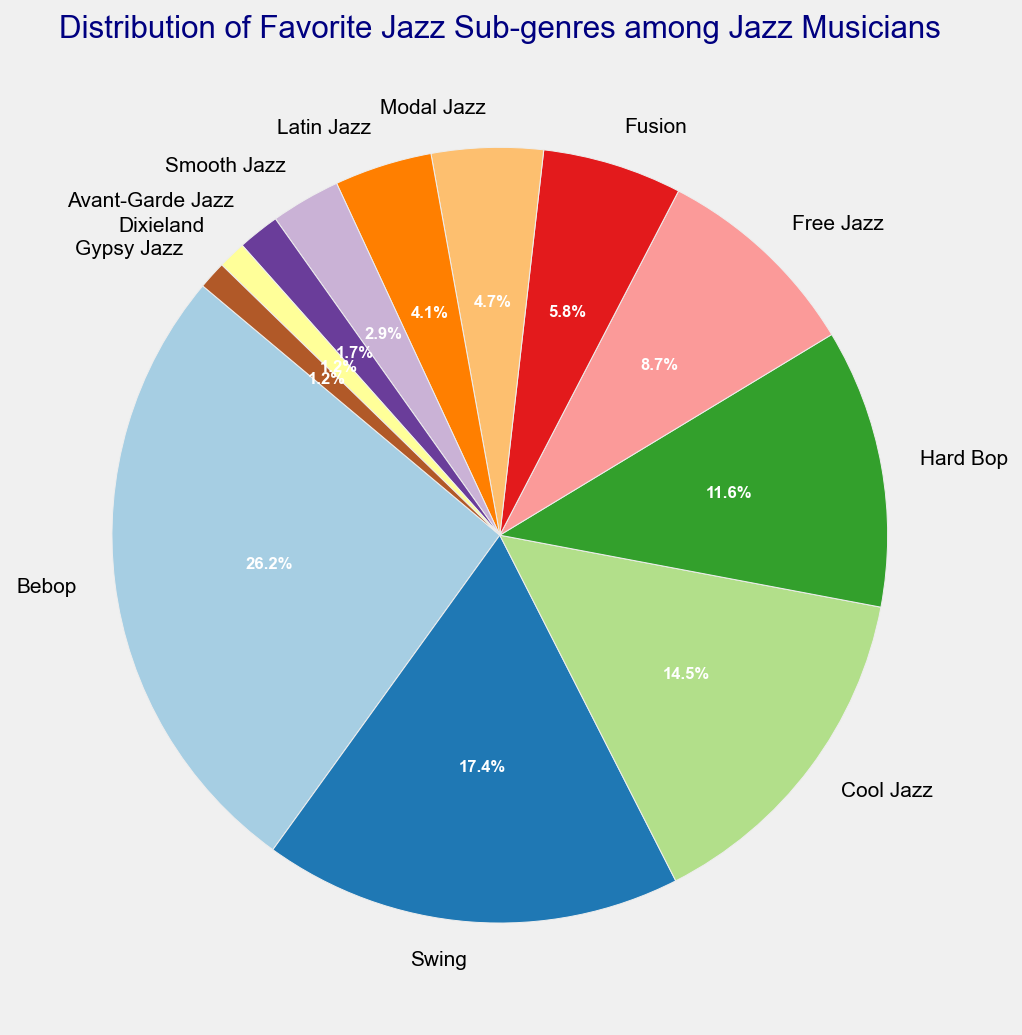What is the most popular jazz sub-genre among jazz musicians? The most popular jazz sub-genre will have the largest slice in the pie chart. By examining the chart, Bebop has the largest percentage.
Answer: Bebop Which sub-genre has a bigger slice: Swing or Free Jazz? Identify the slices for Swing and Free Jazz. Swing has a slice labeled 17.2%, and Free Jazz has 8.6%, so Swing has a larger slice.
Answer: Swing How many sub-genres have a percentage less than 10%? Count the slices with percentages under 10%. These are Free Jazz, Fusion, Modal Jazz, Latin Jazz, Smooth Jazz, Avant-Garde Jazz, Dixieland, and Gypsy Jazz, making a total of 8 sub-genres.
Answer: 8 What is the combined percentage of Hard Bop, Free Jazz, and Fusion? Add the percentages given for Hard Bop (11.5%), Free Jazz (8.6%), and Fusion (5.7%). The combined percentage is 11.5% + 8.6% + 5.7% = 25.8%.
Answer: 25.8% What is the percentage difference between Bebop and Modal Jazz? Subtract the percentage of Modal Jazz from Bebop. Bebop has 25.9% and Modal Jazz has 4.6%, so the difference is 25.9% - 4.6% = 21.3%.
Answer: 21.3% Which slice represents the smallest sub-genre? The smallest slice in the pie chart will correspond to the smallest numerical count. From the chart, this is a tie between Dixieland and Gypsy Jazz, each with 1.1%.
Answer: Dixieland and Gypsy Jazz How does the count for Smooth Jazz compare with that of Latin Jazz? Look at the counts for each. Smooth Jazz has 5 counts and Latin Jazz has 7 counts, so Latin Jazz has 2 more counts than Smooth Jazz.
Answer: Latin Jazz has 2 more counts If you were to combine Bebop and Cool Jazz, what percentage of musicians prefer these combined sub-genres? Add the percentages for Bebop (25.9%) and Cool Jazz (14.4%). The total percentage is 25.9% + 14.4% = 40.3%.
Answer: 40.3% Which sub-genres together account for just over 50% of the preferences? Begin with the largest percentages and add until you exceed 50%. Bebop (25.9%), Swing (17.2%), and Cool Jazz (14.4%) when combined give 25.9% + 17.2% + 14.4% = 57.5%.
Answer: Bebop, Swing, Cool Jazz Is there any sub-genre that has exactly half the percentage of Swing? Swing has 17.2%. Half of that is 8.6%. Free Jazz exactly matches 8.6%, so it’s exactly half of Swing's percentage.
Answer: Free Jazz 